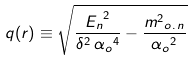<formula> <loc_0><loc_0><loc_500><loc_500>q ( r ) \equiv \sqrt { \frac { { E _ { n } } ^ { 2 } } { \delta ^ { 2 } \, { \alpha _ { o } } ^ { 4 } } - \frac { { { m ^ { 2 } } _ { o . \, n } } } { { \alpha _ { o } } ^ { 2 } } }</formula> 